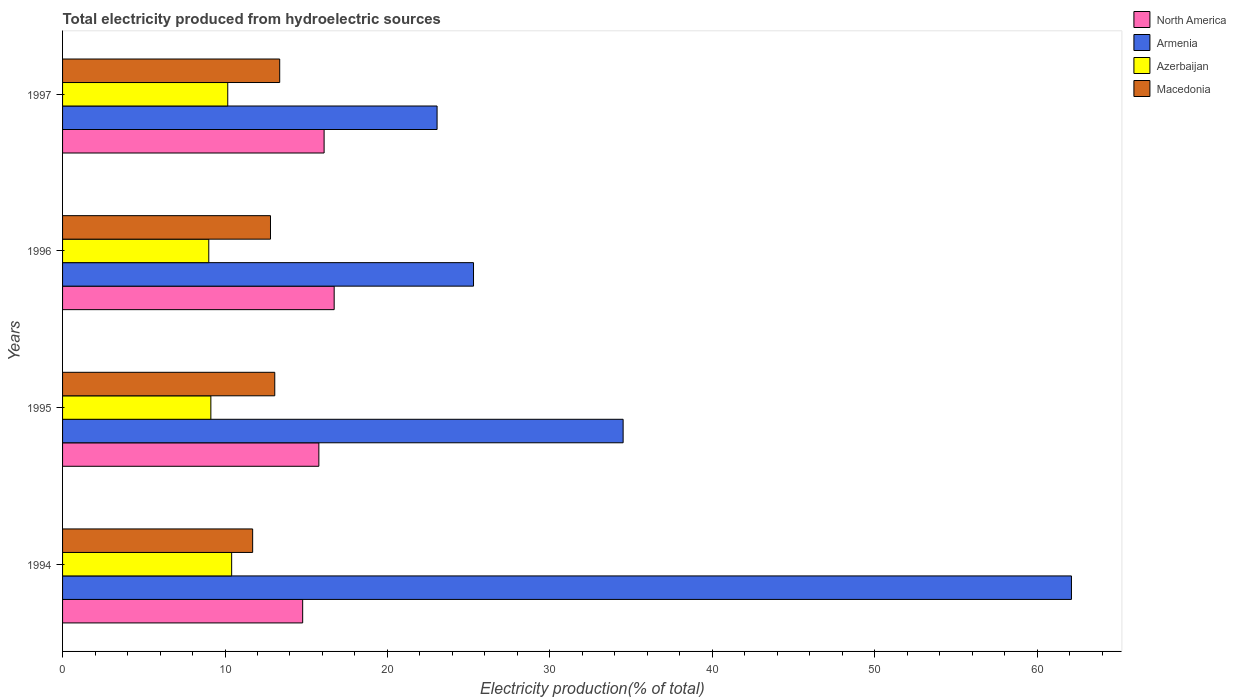How many bars are there on the 2nd tick from the top?
Keep it short and to the point. 4. In how many cases, is the number of bars for a given year not equal to the number of legend labels?
Offer a terse response. 0. What is the total electricity produced in Armenia in 1995?
Your answer should be compact. 34.51. Across all years, what is the maximum total electricity produced in Azerbaijan?
Make the answer very short. 10.41. Across all years, what is the minimum total electricity produced in Azerbaijan?
Keep it short and to the point. 9. In which year was the total electricity produced in Armenia minimum?
Provide a succinct answer. 1997. What is the total total electricity produced in Azerbaijan in the graph?
Your answer should be compact. 38.71. What is the difference between the total electricity produced in Macedonia in 1995 and that in 1997?
Provide a short and direct response. -0.3. What is the difference between the total electricity produced in Azerbaijan in 1994 and the total electricity produced in Macedonia in 1997?
Make the answer very short. -2.96. What is the average total electricity produced in Azerbaijan per year?
Offer a very short reply. 9.68. In the year 1994, what is the difference between the total electricity produced in North America and total electricity produced in Macedonia?
Keep it short and to the point. 3.08. What is the ratio of the total electricity produced in Macedonia in 1994 to that in 1995?
Provide a succinct answer. 0.9. Is the total electricity produced in Azerbaijan in 1994 less than that in 1995?
Give a very brief answer. No. What is the difference between the highest and the second highest total electricity produced in North America?
Provide a short and direct response. 0.62. What is the difference between the highest and the lowest total electricity produced in North America?
Offer a terse response. 1.94. Is the sum of the total electricity produced in Macedonia in 1995 and 1996 greater than the maximum total electricity produced in Azerbaijan across all years?
Give a very brief answer. Yes. What does the 1st bar from the top in 1995 represents?
Make the answer very short. Macedonia. What does the 2nd bar from the bottom in 1996 represents?
Provide a short and direct response. Armenia. Are all the bars in the graph horizontal?
Provide a succinct answer. Yes. Does the graph contain any zero values?
Offer a very short reply. No. Where does the legend appear in the graph?
Make the answer very short. Top right. How many legend labels are there?
Ensure brevity in your answer.  4. How are the legend labels stacked?
Offer a very short reply. Vertical. What is the title of the graph?
Ensure brevity in your answer.  Total electricity produced from hydroelectric sources. What is the label or title of the Y-axis?
Provide a succinct answer. Years. What is the Electricity production(% of total) in North America in 1994?
Keep it short and to the point. 14.78. What is the Electricity production(% of total) in Armenia in 1994?
Ensure brevity in your answer.  62.11. What is the Electricity production(% of total) in Azerbaijan in 1994?
Your response must be concise. 10.41. What is the Electricity production(% of total) of Macedonia in 1994?
Offer a terse response. 11.7. What is the Electricity production(% of total) of North America in 1995?
Make the answer very short. 15.78. What is the Electricity production(% of total) of Armenia in 1995?
Ensure brevity in your answer.  34.51. What is the Electricity production(% of total) of Azerbaijan in 1995?
Provide a succinct answer. 9.13. What is the Electricity production(% of total) of Macedonia in 1995?
Give a very brief answer. 13.06. What is the Electricity production(% of total) of North America in 1996?
Your answer should be compact. 16.72. What is the Electricity production(% of total) in Armenia in 1996?
Offer a very short reply. 25.3. What is the Electricity production(% of total) in Azerbaijan in 1996?
Keep it short and to the point. 9. What is the Electricity production(% of total) of Macedonia in 1996?
Ensure brevity in your answer.  12.8. What is the Electricity production(% of total) of North America in 1997?
Your response must be concise. 16.1. What is the Electricity production(% of total) of Armenia in 1997?
Ensure brevity in your answer.  23.06. What is the Electricity production(% of total) of Azerbaijan in 1997?
Offer a very short reply. 10.17. What is the Electricity production(% of total) in Macedonia in 1997?
Offer a very short reply. 13.37. Across all years, what is the maximum Electricity production(% of total) in North America?
Offer a very short reply. 16.72. Across all years, what is the maximum Electricity production(% of total) in Armenia?
Provide a succinct answer. 62.11. Across all years, what is the maximum Electricity production(% of total) of Azerbaijan?
Give a very brief answer. 10.41. Across all years, what is the maximum Electricity production(% of total) of Macedonia?
Offer a terse response. 13.37. Across all years, what is the minimum Electricity production(% of total) of North America?
Offer a terse response. 14.78. Across all years, what is the minimum Electricity production(% of total) of Armenia?
Your answer should be very brief. 23.06. Across all years, what is the minimum Electricity production(% of total) in Azerbaijan?
Offer a very short reply. 9. Across all years, what is the minimum Electricity production(% of total) in Macedonia?
Ensure brevity in your answer.  11.7. What is the total Electricity production(% of total) in North America in the graph?
Your answer should be very brief. 63.38. What is the total Electricity production(% of total) in Armenia in the graph?
Your response must be concise. 144.97. What is the total Electricity production(% of total) in Azerbaijan in the graph?
Your answer should be very brief. 38.71. What is the total Electricity production(% of total) in Macedonia in the graph?
Provide a short and direct response. 50.93. What is the difference between the Electricity production(% of total) in North America in 1994 and that in 1995?
Provide a succinct answer. -1. What is the difference between the Electricity production(% of total) of Armenia in 1994 and that in 1995?
Keep it short and to the point. 27.6. What is the difference between the Electricity production(% of total) in Azerbaijan in 1994 and that in 1995?
Your response must be concise. 1.28. What is the difference between the Electricity production(% of total) in Macedonia in 1994 and that in 1995?
Your answer should be compact. -1.36. What is the difference between the Electricity production(% of total) of North America in 1994 and that in 1996?
Make the answer very short. -1.94. What is the difference between the Electricity production(% of total) in Armenia in 1994 and that in 1996?
Offer a very short reply. 36.81. What is the difference between the Electricity production(% of total) of Azerbaijan in 1994 and that in 1996?
Your answer should be very brief. 1.41. What is the difference between the Electricity production(% of total) in Macedonia in 1994 and that in 1996?
Offer a very short reply. -1.1. What is the difference between the Electricity production(% of total) in North America in 1994 and that in 1997?
Ensure brevity in your answer.  -1.32. What is the difference between the Electricity production(% of total) in Armenia in 1994 and that in 1997?
Offer a very short reply. 39.05. What is the difference between the Electricity production(% of total) of Azerbaijan in 1994 and that in 1997?
Offer a very short reply. 0.24. What is the difference between the Electricity production(% of total) of Macedonia in 1994 and that in 1997?
Offer a very short reply. -1.66. What is the difference between the Electricity production(% of total) in North America in 1995 and that in 1996?
Your response must be concise. -0.94. What is the difference between the Electricity production(% of total) in Armenia in 1995 and that in 1996?
Ensure brevity in your answer.  9.21. What is the difference between the Electricity production(% of total) of Azerbaijan in 1995 and that in 1996?
Make the answer very short. 0.13. What is the difference between the Electricity production(% of total) of Macedonia in 1995 and that in 1996?
Make the answer very short. 0.26. What is the difference between the Electricity production(% of total) in North America in 1995 and that in 1997?
Offer a very short reply. -0.32. What is the difference between the Electricity production(% of total) of Armenia in 1995 and that in 1997?
Ensure brevity in your answer.  11.45. What is the difference between the Electricity production(% of total) of Azerbaijan in 1995 and that in 1997?
Provide a short and direct response. -1.04. What is the difference between the Electricity production(% of total) of Macedonia in 1995 and that in 1997?
Keep it short and to the point. -0.3. What is the difference between the Electricity production(% of total) in North America in 1996 and that in 1997?
Give a very brief answer. 0.62. What is the difference between the Electricity production(% of total) in Armenia in 1996 and that in 1997?
Offer a very short reply. 2.24. What is the difference between the Electricity production(% of total) in Azerbaijan in 1996 and that in 1997?
Your response must be concise. -1.17. What is the difference between the Electricity production(% of total) of Macedonia in 1996 and that in 1997?
Provide a succinct answer. -0.57. What is the difference between the Electricity production(% of total) of North America in 1994 and the Electricity production(% of total) of Armenia in 1995?
Provide a succinct answer. -19.73. What is the difference between the Electricity production(% of total) of North America in 1994 and the Electricity production(% of total) of Azerbaijan in 1995?
Provide a short and direct response. 5.65. What is the difference between the Electricity production(% of total) in North America in 1994 and the Electricity production(% of total) in Macedonia in 1995?
Provide a short and direct response. 1.72. What is the difference between the Electricity production(% of total) of Armenia in 1994 and the Electricity production(% of total) of Azerbaijan in 1995?
Ensure brevity in your answer.  52.98. What is the difference between the Electricity production(% of total) in Armenia in 1994 and the Electricity production(% of total) in Macedonia in 1995?
Give a very brief answer. 49.04. What is the difference between the Electricity production(% of total) of Azerbaijan in 1994 and the Electricity production(% of total) of Macedonia in 1995?
Your answer should be very brief. -2.65. What is the difference between the Electricity production(% of total) of North America in 1994 and the Electricity production(% of total) of Armenia in 1996?
Offer a terse response. -10.52. What is the difference between the Electricity production(% of total) in North America in 1994 and the Electricity production(% of total) in Azerbaijan in 1996?
Your response must be concise. 5.78. What is the difference between the Electricity production(% of total) in North America in 1994 and the Electricity production(% of total) in Macedonia in 1996?
Give a very brief answer. 1.98. What is the difference between the Electricity production(% of total) in Armenia in 1994 and the Electricity production(% of total) in Azerbaijan in 1996?
Ensure brevity in your answer.  53.11. What is the difference between the Electricity production(% of total) of Armenia in 1994 and the Electricity production(% of total) of Macedonia in 1996?
Ensure brevity in your answer.  49.31. What is the difference between the Electricity production(% of total) in Azerbaijan in 1994 and the Electricity production(% of total) in Macedonia in 1996?
Make the answer very short. -2.39. What is the difference between the Electricity production(% of total) in North America in 1994 and the Electricity production(% of total) in Armenia in 1997?
Your answer should be compact. -8.27. What is the difference between the Electricity production(% of total) of North America in 1994 and the Electricity production(% of total) of Azerbaijan in 1997?
Offer a terse response. 4.61. What is the difference between the Electricity production(% of total) of North America in 1994 and the Electricity production(% of total) of Macedonia in 1997?
Keep it short and to the point. 1.41. What is the difference between the Electricity production(% of total) of Armenia in 1994 and the Electricity production(% of total) of Azerbaijan in 1997?
Provide a succinct answer. 51.94. What is the difference between the Electricity production(% of total) in Armenia in 1994 and the Electricity production(% of total) in Macedonia in 1997?
Give a very brief answer. 48.74. What is the difference between the Electricity production(% of total) of Azerbaijan in 1994 and the Electricity production(% of total) of Macedonia in 1997?
Ensure brevity in your answer.  -2.96. What is the difference between the Electricity production(% of total) of North America in 1995 and the Electricity production(% of total) of Armenia in 1996?
Give a very brief answer. -9.52. What is the difference between the Electricity production(% of total) of North America in 1995 and the Electricity production(% of total) of Azerbaijan in 1996?
Your answer should be compact. 6.78. What is the difference between the Electricity production(% of total) of North America in 1995 and the Electricity production(% of total) of Macedonia in 1996?
Ensure brevity in your answer.  2.98. What is the difference between the Electricity production(% of total) in Armenia in 1995 and the Electricity production(% of total) in Azerbaijan in 1996?
Keep it short and to the point. 25.51. What is the difference between the Electricity production(% of total) in Armenia in 1995 and the Electricity production(% of total) in Macedonia in 1996?
Provide a succinct answer. 21.71. What is the difference between the Electricity production(% of total) of Azerbaijan in 1995 and the Electricity production(% of total) of Macedonia in 1996?
Keep it short and to the point. -3.67. What is the difference between the Electricity production(% of total) of North America in 1995 and the Electricity production(% of total) of Armenia in 1997?
Provide a short and direct response. -7.28. What is the difference between the Electricity production(% of total) in North America in 1995 and the Electricity production(% of total) in Azerbaijan in 1997?
Offer a terse response. 5.61. What is the difference between the Electricity production(% of total) in North America in 1995 and the Electricity production(% of total) in Macedonia in 1997?
Make the answer very short. 2.41. What is the difference between the Electricity production(% of total) in Armenia in 1995 and the Electricity production(% of total) in Azerbaijan in 1997?
Provide a succinct answer. 24.34. What is the difference between the Electricity production(% of total) in Armenia in 1995 and the Electricity production(% of total) in Macedonia in 1997?
Your answer should be compact. 21.14. What is the difference between the Electricity production(% of total) in Azerbaijan in 1995 and the Electricity production(% of total) in Macedonia in 1997?
Your answer should be compact. -4.24. What is the difference between the Electricity production(% of total) in North America in 1996 and the Electricity production(% of total) in Armenia in 1997?
Provide a succinct answer. -6.34. What is the difference between the Electricity production(% of total) of North America in 1996 and the Electricity production(% of total) of Azerbaijan in 1997?
Your response must be concise. 6.55. What is the difference between the Electricity production(% of total) in North America in 1996 and the Electricity production(% of total) in Macedonia in 1997?
Provide a short and direct response. 3.35. What is the difference between the Electricity production(% of total) in Armenia in 1996 and the Electricity production(% of total) in Azerbaijan in 1997?
Provide a short and direct response. 15.13. What is the difference between the Electricity production(% of total) of Armenia in 1996 and the Electricity production(% of total) of Macedonia in 1997?
Provide a short and direct response. 11.93. What is the difference between the Electricity production(% of total) in Azerbaijan in 1996 and the Electricity production(% of total) in Macedonia in 1997?
Your answer should be compact. -4.37. What is the average Electricity production(% of total) in North America per year?
Provide a short and direct response. 15.84. What is the average Electricity production(% of total) of Armenia per year?
Your response must be concise. 36.24. What is the average Electricity production(% of total) in Azerbaijan per year?
Your response must be concise. 9.68. What is the average Electricity production(% of total) in Macedonia per year?
Provide a succinct answer. 12.73. In the year 1994, what is the difference between the Electricity production(% of total) of North America and Electricity production(% of total) of Armenia?
Keep it short and to the point. -47.33. In the year 1994, what is the difference between the Electricity production(% of total) in North America and Electricity production(% of total) in Azerbaijan?
Make the answer very short. 4.37. In the year 1994, what is the difference between the Electricity production(% of total) in North America and Electricity production(% of total) in Macedonia?
Your response must be concise. 3.08. In the year 1994, what is the difference between the Electricity production(% of total) in Armenia and Electricity production(% of total) in Azerbaijan?
Make the answer very short. 51.7. In the year 1994, what is the difference between the Electricity production(% of total) of Armenia and Electricity production(% of total) of Macedonia?
Keep it short and to the point. 50.4. In the year 1994, what is the difference between the Electricity production(% of total) in Azerbaijan and Electricity production(% of total) in Macedonia?
Give a very brief answer. -1.29. In the year 1995, what is the difference between the Electricity production(% of total) in North America and Electricity production(% of total) in Armenia?
Provide a short and direct response. -18.73. In the year 1995, what is the difference between the Electricity production(% of total) of North America and Electricity production(% of total) of Azerbaijan?
Your answer should be compact. 6.65. In the year 1995, what is the difference between the Electricity production(% of total) of North America and Electricity production(% of total) of Macedonia?
Give a very brief answer. 2.71. In the year 1995, what is the difference between the Electricity production(% of total) of Armenia and Electricity production(% of total) of Azerbaijan?
Provide a short and direct response. 25.38. In the year 1995, what is the difference between the Electricity production(% of total) of Armenia and Electricity production(% of total) of Macedonia?
Provide a short and direct response. 21.45. In the year 1995, what is the difference between the Electricity production(% of total) in Azerbaijan and Electricity production(% of total) in Macedonia?
Ensure brevity in your answer.  -3.93. In the year 1996, what is the difference between the Electricity production(% of total) in North America and Electricity production(% of total) in Armenia?
Offer a very short reply. -8.58. In the year 1996, what is the difference between the Electricity production(% of total) of North America and Electricity production(% of total) of Azerbaijan?
Provide a short and direct response. 7.72. In the year 1996, what is the difference between the Electricity production(% of total) of North America and Electricity production(% of total) of Macedonia?
Ensure brevity in your answer.  3.92. In the year 1996, what is the difference between the Electricity production(% of total) in Armenia and Electricity production(% of total) in Azerbaijan?
Your answer should be very brief. 16.3. In the year 1996, what is the difference between the Electricity production(% of total) in Armenia and Electricity production(% of total) in Macedonia?
Keep it short and to the point. 12.5. In the year 1996, what is the difference between the Electricity production(% of total) in Azerbaijan and Electricity production(% of total) in Macedonia?
Provide a short and direct response. -3.8. In the year 1997, what is the difference between the Electricity production(% of total) of North America and Electricity production(% of total) of Armenia?
Your answer should be compact. -6.96. In the year 1997, what is the difference between the Electricity production(% of total) of North America and Electricity production(% of total) of Azerbaijan?
Ensure brevity in your answer.  5.93. In the year 1997, what is the difference between the Electricity production(% of total) of North America and Electricity production(% of total) of Macedonia?
Your answer should be very brief. 2.73. In the year 1997, what is the difference between the Electricity production(% of total) of Armenia and Electricity production(% of total) of Azerbaijan?
Make the answer very short. 12.89. In the year 1997, what is the difference between the Electricity production(% of total) of Armenia and Electricity production(% of total) of Macedonia?
Provide a short and direct response. 9.69. In the year 1997, what is the difference between the Electricity production(% of total) in Azerbaijan and Electricity production(% of total) in Macedonia?
Offer a very short reply. -3.2. What is the ratio of the Electricity production(% of total) in North America in 1994 to that in 1995?
Provide a short and direct response. 0.94. What is the ratio of the Electricity production(% of total) of Armenia in 1994 to that in 1995?
Make the answer very short. 1.8. What is the ratio of the Electricity production(% of total) in Azerbaijan in 1994 to that in 1995?
Offer a terse response. 1.14. What is the ratio of the Electricity production(% of total) in Macedonia in 1994 to that in 1995?
Your answer should be compact. 0.9. What is the ratio of the Electricity production(% of total) of North America in 1994 to that in 1996?
Provide a succinct answer. 0.88. What is the ratio of the Electricity production(% of total) of Armenia in 1994 to that in 1996?
Make the answer very short. 2.46. What is the ratio of the Electricity production(% of total) in Azerbaijan in 1994 to that in 1996?
Keep it short and to the point. 1.16. What is the ratio of the Electricity production(% of total) of Macedonia in 1994 to that in 1996?
Ensure brevity in your answer.  0.91. What is the ratio of the Electricity production(% of total) in North America in 1994 to that in 1997?
Provide a short and direct response. 0.92. What is the ratio of the Electricity production(% of total) of Armenia in 1994 to that in 1997?
Make the answer very short. 2.69. What is the ratio of the Electricity production(% of total) of Azerbaijan in 1994 to that in 1997?
Give a very brief answer. 1.02. What is the ratio of the Electricity production(% of total) of Macedonia in 1994 to that in 1997?
Offer a very short reply. 0.88. What is the ratio of the Electricity production(% of total) of North America in 1995 to that in 1996?
Give a very brief answer. 0.94. What is the ratio of the Electricity production(% of total) in Armenia in 1995 to that in 1996?
Your response must be concise. 1.36. What is the ratio of the Electricity production(% of total) in Azerbaijan in 1995 to that in 1996?
Ensure brevity in your answer.  1.01. What is the ratio of the Electricity production(% of total) of Macedonia in 1995 to that in 1996?
Ensure brevity in your answer.  1.02. What is the ratio of the Electricity production(% of total) of North America in 1995 to that in 1997?
Keep it short and to the point. 0.98. What is the ratio of the Electricity production(% of total) in Armenia in 1995 to that in 1997?
Your response must be concise. 1.5. What is the ratio of the Electricity production(% of total) of Azerbaijan in 1995 to that in 1997?
Give a very brief answer. 0.9. What is the ratio of the Electricity production(% of total) of Macedonia in 1995 to that in 1997?
Your answer should be compact. 0.98. What is the ratio of the Electricity production(% of total) of Armenia in 1996 to that in 1997?
Offer a terse response. 1.1. What is the ratio of the Electricity production(% of total) in Azerbaijan in 1996 to that in 1997?
Keep it short and to the point. 0.89. What is the ratio of the Electricity production(% of total) in Macedonia in 1996 to that in 1997?
Make the answer very short. 0.96. What is the difference between the highest and the second highest Electricity production(% of total) of North America?
Your answer should be compact. 0.62. What is the difference between the highest and the second highest Electricity production(% of total) of Armenia?
Offer a terse response. 27.6. What is the difference between the highest and the second highest Electricity production(% of total) of Azerbaijan?
Your response must be concise. 0.24. What is the difference between the highest and the second highest Electricity production(% of total) of Macedonia?
Keep it short and to the point. 0.3. What is the difference between the highest and the lowest Electricity production(% of total) in North America?
Give a very brief answer. 1.94. What is the difference between the highest and the lowest Electricity production(% of total) of Armenia?
Ensure brevity in your answer.  39.05. What is the difference between the highest and the lowest Electricity production(% of total) in Azerbaijan?
Keep it short and to the point. 1.41. What is the difference between the highest and the lowest Electricity production(% of total) in Macedonia?
Provide a short and direct response. 1.66. 